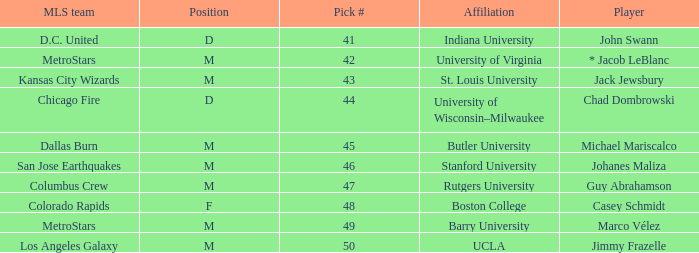Which MLS team has the #41 pick? D.C. United. Would you be able to parse every entry in this table? {'header': ['MLS team', 'Position', 'Pick #', 'Affiliation', 'Player'], 'rows': [['D.C. United', 'D', '41', 'Indiana University', 'John Swann'], ['MetroStars', 'M', '42', 'University of Virginia', '* Jacob LeBlanc'], ['Kansas City Wizards', 'M', '43', 'St. Louis University', 'Jack Jewsbury'], ['Chicago Fire', 'D', '44', 'University of Wisconsin–Milwaukee', 'Chad Dombrowski'], ['Dallas Burn', 'M', '45', 'Butler University', 'Michael Mariscalco'], ['San Jose Earthquakes', 'M', '46', 'Stanford University', 'Johanes Maliza'], ['Columbus Crew', 'M', '47', 'Rutgers University', 'Guy Abrahamson'], ['Colorado Rapids', 'F', '48', 'Boston College', 'Casey Schmidt'], ['MetroStars', 'M', '49', 'Barry University', 'Marco Vélez'], ['Los Angeles Galaxy', 'M', '50', 'UCLA', 'Jimmy Frazelle']]} 